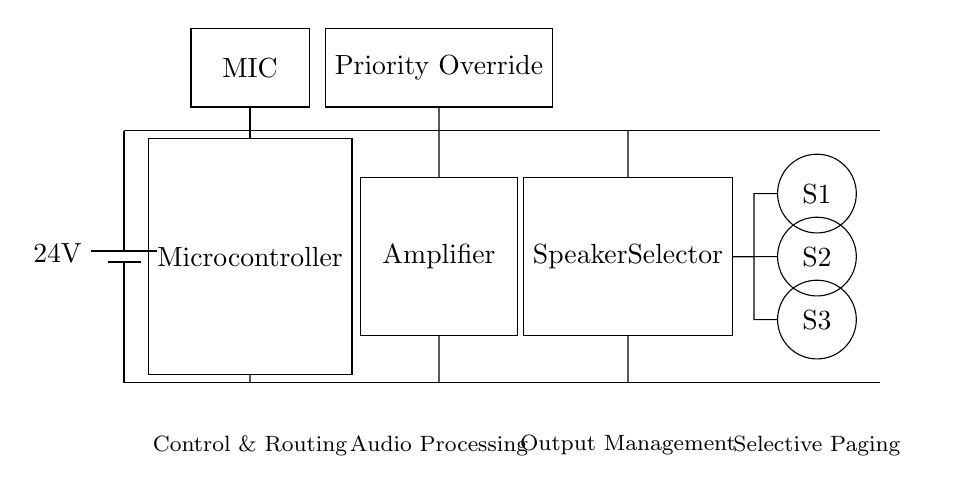What is the voltage of this circuit? The voltage is twenty-four volts, as indicated by the battery symbol at the beginning of the main power supply.
Answer: twenty-four volts What component manages audio processing? The component that manages audio processing is the amplifier, which is labeled and prominently placed in the center of the circuit diagram.
Answer: amplifier How many speakers are connected in the system? There are three speakers connected, as represented by the circles labeled S1, S2, and S3 on the right side of the diagram.
Answer: three What is the function of the microphone in this circuit? The microphone's function is to capture audio input, which is shown as the labeled rectangle at the top of the circuit connecting to the microcontroller.
Answer: audio input Which component allows for priority override? The priority override is provided by the rectangle labeled "Priority Override," which is located above the amplifier in the diagram.
Answer: Priority Override What role does the speaker selector play in this intercom system? The speaker selector determines which of the connected speakers receive the audio output, visible in the diagram as a block connected to all three speakers.
Answer: output management 